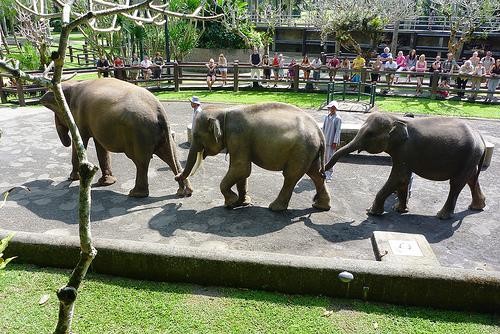Explain the landscape within the image, such as grass and other features. There is a grassy area around and in front of a cement platform where the elephants are walking, and a tree with a visible trunk near the enclosure. Briefly describe the setting in which the elephants and the audience interact. A zoo or an animal park, with a grassy area, a cement platform, and a wooden fence separating the elephants from the people watching them perform. What are the people in the image observing and how are they positioned? People are watching the elephants performing in a show, leaning on a wooden fence, and some are standing or sitting on the fence. Who is responsible for handling the elephants in the image?  Two elephant trainers, one in charge of the elephants, and a caretaker are responsible for handling the elephants. Describe the specific part of the image where the elephants are connected. Each elephant has its trunk holding the tail of the elephant in front of it, creating a connected line of elephants. Identify the main focal point of the image and what it entails. A group of elephants walking together, with trunks and tails connected, arranged from largest to smallest, in an enclosure with people watching. Mention the type of fence and its purpose in the image. A wooden and semi-circular fence with people leaning or sitting on it, serves to separate the elephants from the crowd. What are some of the distinctive characteristics of the elephants in the picture? There are three elephants, one with long tusks, and they are arranged in descending order of size - largest to smallest. What is the predominant emotion of the elephants in the image? The elephants appear docile and calm while walking together and performing for the audience. Highlight any unique sightings or actions from people in the image. A person in a black top and light-colored shorts standing on the fence, another person wearing a hat watching the elephants, and someone sitting on the bottom rail of the fence. What type of fence separates the elephants and the crowd? Wooden fence with lots of people standing beside it. Which of the trainers is wearing a blue shirt? No information about shirt colors is provided in the object list. Asking about the color of the trainers' shirts is misleading, as we cannot determine this information from the given data. Where is the water pond located within the elephant enclosure? There is no mention of a water pond in the object list. Asking for the location of the water pond would be misleading since there is no water pond in the image. Which action is the person in a hat doing in the image? Watching the elephants. What size is the middle elephant of the three elephants? Medium-sized. What are the elephants doing in the image? Walking together in a line and joining trunk to tail. Describe the role of the man interacting with the elephants. He is either a caretaker or a trainer managing the elephants. What are the people in the image doing? Watching the elephants perform while leaning on or sitting on a fence. What unique feature does the middle elephant have? Long tusks. Explain how the elephants appear in the scene. The elephants appear docile and well-managed by their trainers. What can be seen in the background of the image? A building and a tree. Notice the flamingo standing on one leg in the grassy area in front of the cement platform. The list of objects does not contain a flamingo in the image. Mentioning a flamingo standing in the grassy area is misleading because there is no flamingo present in the image. Describe the interaction between the elephants in the scene. They are walking together in a line, with each elephant holding the tail of another elephant with its trunk. Choose the correct description of the individuals near the elephants. A) caretakers and trainers B) visitors and caretakers C) trainers and visitors A) caretakers and trainers Describe the fence that the people are interacting with. A wooden fence with lots of people standing beside and leaning on it; one person is sitting on the bottom rail. Can you identify the giraffe standing beside the elephants in the enclosure? There is no mention of a giraffe in the provided list of objects in the image. Thus, asking about a giraffe would be misleading as it doesn't exist in the image. Point out the balloon vendor among the group of people watching the elephants. There is no mention of a balloon vendor in the list of objects present in the image. An instruction to point out the balloon vendor would be misleading as no balloon vendor exists in the image. Describe the overall event taking place in the image. People are watching a show at a zoo, where three elephants are walking together, and trainers are interacting with them. Describe the grassy areas in the image. There is short green grass around the enclosure and a grassy area in front of the cement platform. What is the overall mood of the scene with the elephants and the people? The elephants appear docile, and the people seem engaged and entertained. Which of the following elements can be observed in the image? A) tree trunk B) elephant's Trunk C) Both C) Both What kind of platform are the elephants walking on? Cement platform. List the main elements you see in the image. Elephants, people, trainers, wooden fence, grass, tree, shadows, cement platform. Look at the lion resting under the tree near the enclosure. The list of objects does not include a lion in the image. Mentioning a lion resting under the tree is misleading as it is not present in the image. Based on the shadows, what is the arrangement of the three elephants in the scene? Arranged from largest to smallest. 